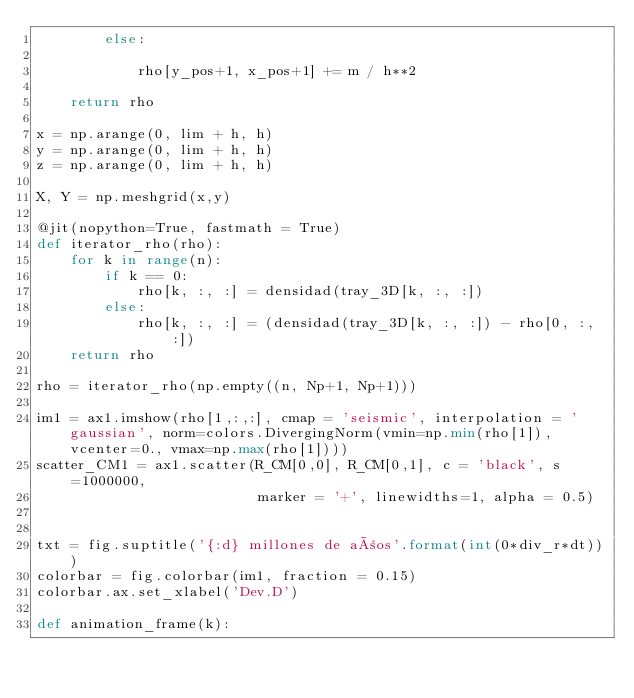<code> <loc_0><loc_0><loc_500><loc_500><_Python_>        else:
        
            rho[y_pos+1, x_pos+1] += m / h**2

    return rho

x = np.arange(0, lim + h, h)
y = np.arange(0, lim + h, h)
z = np.arange(0, lim + h, h)

X, Y = np.meshgrid(x,y)

@jit(nopython=True, fastmath = True)
def iterator_rho(rho):
    for k in range(n):
        if k == 0:
            rho[k, :, :] = densidad(tray_3D[k, :, :])
        else:
            rho[k, :, :] = (densidad(tray_3D[k, :, :]) - rho[0, :, :])
    return rho

rho = iterator_rho(np.empty((n, Np+1, Np+1)))

im1 = ax1.imshow(rho[1,:,:], cmap = 'seismic', interpolation = 'gaussian', norm=colors.DivergingNorm(vmin=np.min(rho[1]), vcenter=0., vmax=np.max(rho[1])))
scatter_CM1 = ax1.scatter(R_CM[0,0], R_CM[0,1], c = 'black', s=1000000, 
                          marker = '+', linewidths=1, alpha = 0.5)


txt = fig.suptitle('{:d} millones de años'.format(int(0*div_r*dt)))
colorbar = fig.colorbar(im1, fraction = 0.15)
colorbar.ax.set_xlabel('Dev.D')

def animation_frame(k):
    </code> 